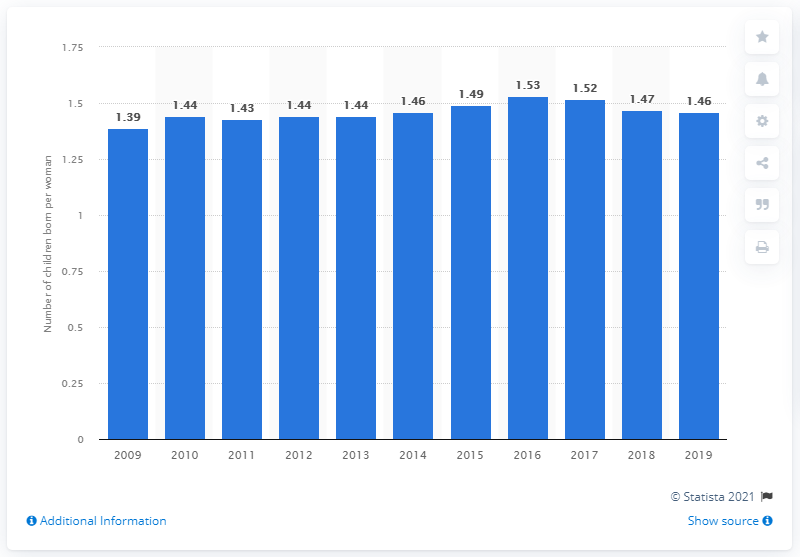Outline some significant characteristics in this image. In 2019, the fertility rate in Austria was 1.46. 